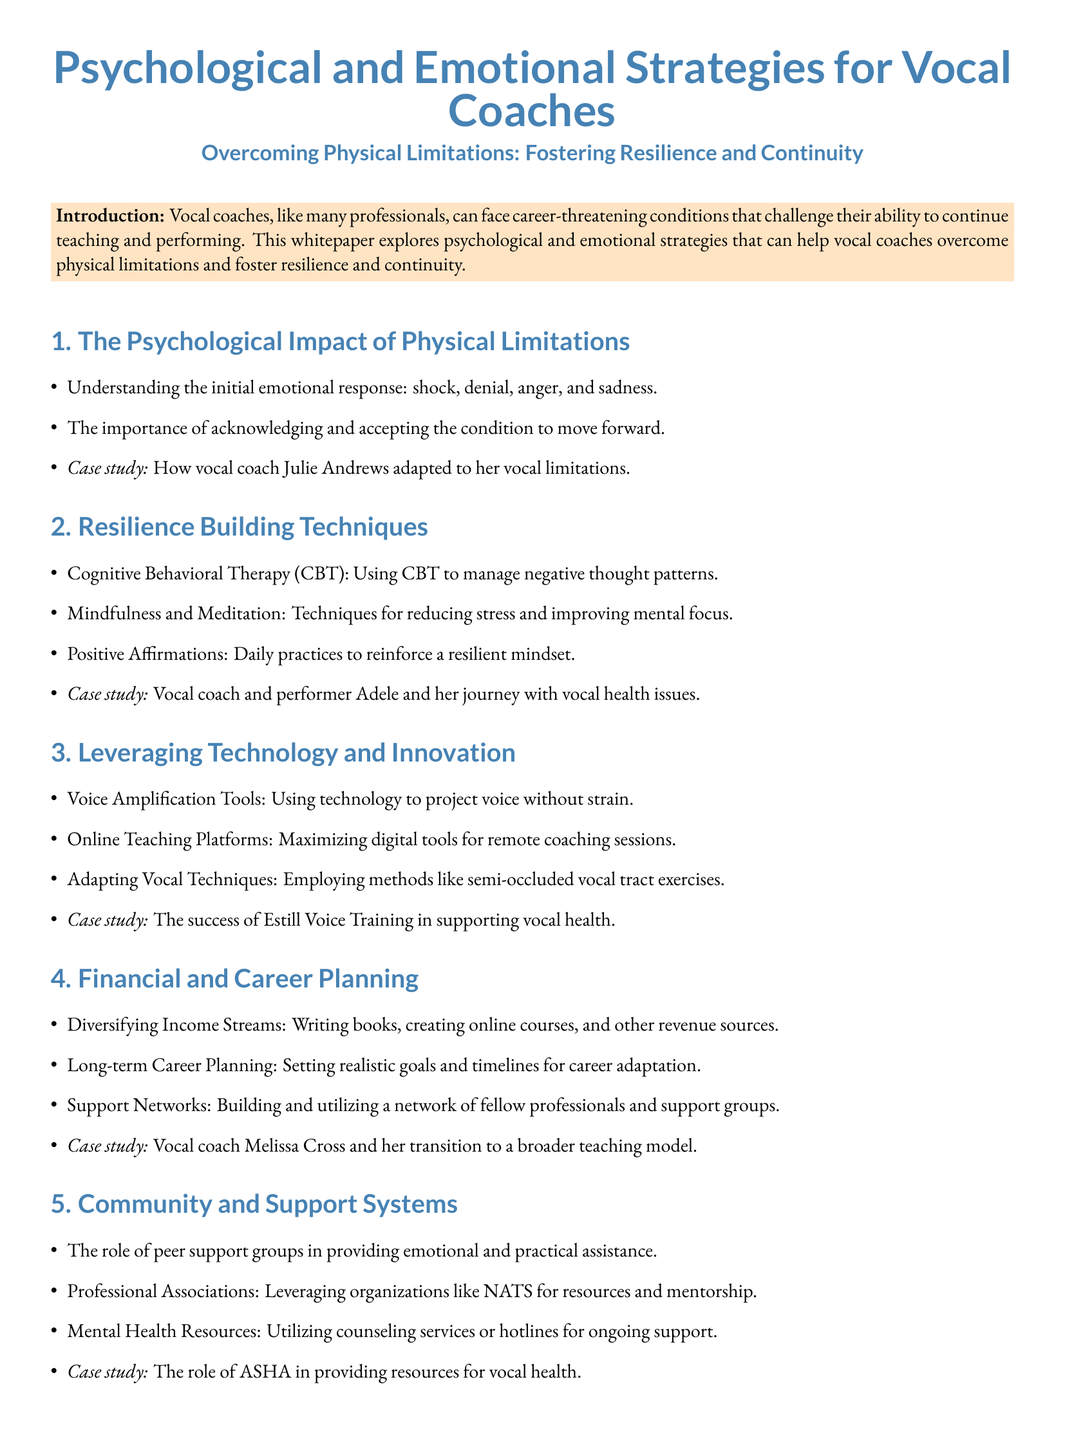What are the initial emotional responses to physical limitations? The document lists several initial emotional responses, including shock, denial, anger, and sadness.
Answer: shock, denial, anger, sadness Who is cited as a case study for adapting to vocal limitations? The document mentions a case study of vocal coach Julie Andrews adapting to her vocal limitations.
Answer: Julie Andrews What technique is suggested for managing negative thought patterns? The whitepaper suggests using Cognitive Behavioral Therapy (CBT) for managing negative thought patterns.
Answer: Cognitive Behavioral Therapy (CBT) What is one strategy for reducing stress mentioned in the document? Mindfulness and Meditation are recommended techniques for reducing stress and improving mental focus.
Answer: Mindfulness and Meditation What does the document recommend for online teaching? It recommends maximizing digital tools for remote coaching sessions as a strategy for online teaching.
Answer: online teaching platforms Which organization offers resources for vocal health? The document refers to the American Speech-Language-Hearing Association (ASHA) as providing resources for vocal health.
Answer: ASHA How does the document categorize the role of peer support groups? It describes peer support groups as providing emotional and practical assistance.
Answer: emotional and practical assistance What does the conclusion emphasize for vocal coaches facing challenges? The conclusion emphasizes embracing resilience and utilizing innovative strategies for overcoming challenges.
Answer: resilience and innovative strategies 